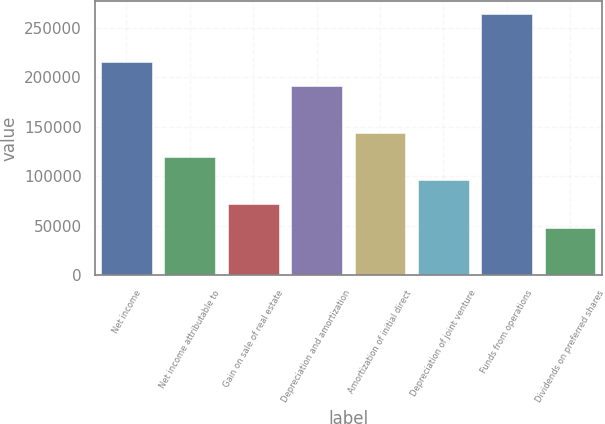Convert chart to OTSL. <chart><loc_0><loc_0><loc_500><loc_500><bar_chart><fcel>Net income<fcel>Net income attributable to<fcel>Gain on sale of real estate<fcel>Depreciation and amortization<fcel>Amortization of initial direct<fcel>Depreciation of joint venture<fcel>Funds from operations<fcel>Dividends on preferred shares<nl><fcel>215657<fcel>119811<fcel>71888.1<fcel>191695<fcel>143772<fcel>95849.5<fcel>263579<fcel>47926.7<nl></chart> 